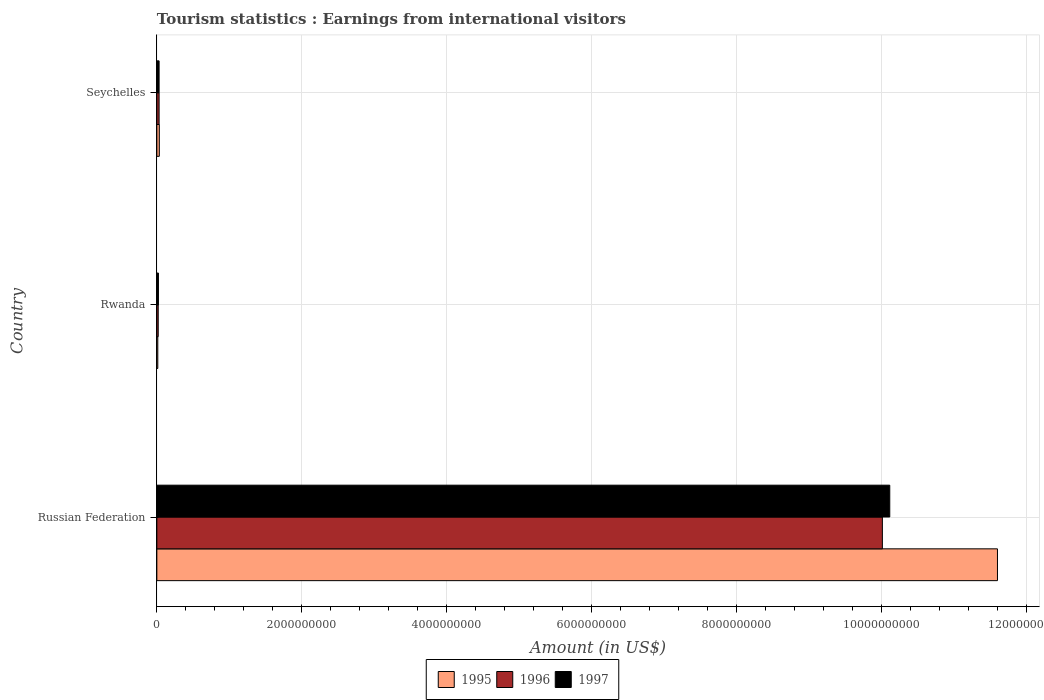How many different coloured bars are there?
Offer a terse response. 3. How many groups of bars are there?
Your answer should be very brief. 3. Are the number of bars per tick equal to the number of legend labels?
Give a very brief answer. Yes. How many bars are there on the 3rd tick from the top?
Give a very brief answer. 3. How many bars are there on the 1st tick from the bottom?
Your response must be concise. 3. What is the label of the 2nd group of bars from the top?
Keep it short and to the point. Rwanda. What is the earnings from international visitors in 1997 in Russian Federation?
Make the answer very short. 1.01e+1. Across all countries, what is the maximum earnings from international visitors in 1995?
Provide a short and direct response. 1.16e+1. Across all countries, what is the minimum earnings from international visitors in 1996?
Provide a short and direct response. 1.90e+07. In which country was the earnings from international visitors in 1997 maximum?
Your answer should be very brief. Russian Federation. In which country was the earnings from international visitors in 1996 minimum?
Provide a short and direct response. Rwanda. What is the total earnings from international visitors in 1997 in the graph?
Your answer should be compact. 1.02e+1. What is the difference between the earnings from international visitors in 1995 in Russian Federation and that in Rwanda?
Your response must be concise. 1.16e+1. What is the difference between the earnings from international visitors in 1995 in Russian Federation and the earnings from international visitors in 1996 in Rwanda?
Your response must be concise. 1.16e+1. What is the average earnings from international visitors in 1995 per country?
Your answer should be compact. 3.88e+09. What is the difference between the earnings from international visitors in 1995 and earnings from international visitors in 1997 in Rwanda?
Ensure brevity in your answer.  -9.00e+06. In how many countries, is the earnings from international visitors in 1995 greater than 9200000000 US$?
Your answer should be very brief. 1. What is the ratio of the earnings from international visitors in 1997 in Russian Federation to that in Seychelles?
Keep it short and to the point. 326.23. Is the difference between the earnings from international visitors in 1995 in Russian Federation and Rwanda greater than the difference between the earnings from international visitors in 1997 in Russian Federation and Rwanda?
Keep it short and to the point. Yes. What is the difference between the highest and the second highest earnings from international visitors in 1997?
Give a very brief answer. 1.01e+1. What is the difference between the highest and the lowest earnings from international visitors in 1997?
Keep it short and to the point. 1.01e+1. In how many countries, is the earnings from international visitors in 1996 greater than the average earnings from international visitors in 1996 taken over all countries?
Offer a terse response. 1. Is the sum of the earnings from international visitors in 1997 in Russian Federation and Rwanda greater than the maximum earnings from international visitors in 1995 across all countries?
Your response must be concise. No. What does the 1st bar from the bottom in Seychelles represents?
Offer a very short reply. 1995. Are the values on the major ticks of X-axis written in scientific E-notation?
Your answer should be compact. No. Does the graph contain grids?
Provide a short and direct response. Yes. Where does the legend appear in the graph?
Your answer should be very brief. Bottom center. How are the legend labels stacked?
Offer a terse response. Horizontal. What is the title of the graph?
Ensure brevity in your answer.  Tourism statistics : Earnings from international visitors. Does "1987" appear as one of the legend labels in the graph?
Keep it short and to the point. No. What is the label or title of the X-axis?
Make the answer very short. Amount (in US$). What is the label or title of the Y-axis?
Keep it short and to the point. Country. What is the Amount (in US$) of 1995 in Russian Federation?
Offer a very short reply. 1.16e+1. What is the Amount (in US$) of 1996 in Russian Federation?
Your response must be concise. 1.00e+1. What is the Amount (in US$) of 1997 in Russian Federation?
Give a very brief answer. 1.01e+1. What is the Amount (in US$) of 1995 in Rwanda?
Offer a very short reply. 1.30e+07. What is the Amount (in US$) in 1996 in Rwanda?
Your answer should be compact. 1.90e+07. What is the Amount (in US$) in 1997 in Rwanda?
Provide a short and direct response. 2.20e+07. What is the Amount (in US$) of 1995 in Seychelles?
Your answer should be compact. 3.40e+07. What is the Amount (in US$) of 1996 in Seychelles?
Ensure brevity in your answer.  3.10e+07. What is the Amount (in US$) of 1997 in Seychelles?
Offer a very short reply. 3.10e+07. Across all countries, what is the maximum Amount (in US$) of 1995?
Ensure brevity in your answer.  1.16e+1. Across all countries, what is the maximum Amount (in US$) of 1996?
Your answer should be compact. 1.00e+1. Across all countries, what is the maximum Amount (in US$) in 1997?
Keep it short and to the point. 1.01e+1. Across all countries, what is the minimum Amount (in US$) of 1995?
Your answer should be compact. 1.30e+07. Across all countries, what is the minimum Amount (in US$) of 1996?
Your answer should be compact. 1.90e+07. Across all countries, what is the minimum Amount (in US$) of 1997?
Provide a short and direct response. 2.20e+07. What is the total Amount (in US$) of 1995 in the graph?
Your answer should be compact. 1.16e+1. What is the total Amount (in US$) of 1996 in the graph?
Make the answer very short. 1.01e+1. What is the total Amount (in US$) of 1997 in the graph?
Offer a very short reply. 1.02e+1. What is the difference between the Amount (in US$) in 1995 in Russian Federation and that in Rwanda?
Give a very brief answer. 1.16e+1. What is the difference between the Amount (in US$) in 1996 in Russian Federation and that in Rwanda?
Give a very brief answer. 9.99e+09. What is the difference between the Amount (in US$) in 1997 in Russian Federation and that in Rwanda?
Provide a succinct answer. 1.01e+1. What is the difference between the Amount (in US$) in 1995 in Russian Federation and that in Seychelles?
Make the answer very short. 1.16e+1. What is the difference between the Amount (in US$) of 1996 in Russian Federation and that in Seychelles?
Your answer should be compact. 9.98e+09. What is the difference between the Amount (in US$) of 1997 in Russian Federation and that in Seychelles?
Your answer should be very brief. 1.01e+1. What is the difference between the Amount (in US$) in 1995 in Rwanda and that in Seychelles?
Your response must be concise. -2.10e+07. What is the difference between the Amount (in US$) in 1996 in Rwanda and that in Seychelles?
Keep it short and to the point. -1.20e+07. What is the difference between the Amount (in US$) in 1997 in Rwanda and that in Seychelles?
Your answer should be compact. -9.00e+06. What is the difference between the Amount (in US$) in 1995 in Russian Federation and the Amount (in US$) in 1996 in Rwanda?
Keep it short and to the point. 1.16e+1. What is the difference between the Amount (in US$) in 1995 in Russian Federation and the Amount (in US$) in 1997 in Rwanda?
Ensure brevity in your answer.  1.16e+1. What is the difference between the Amount (in US$) in 1996 in Russian Federation and the Amount (in US$) in 1997 in Rwanda?
Ensure brevity in your answer.  9.99e+09. What is the difference between the Amount (in US$) in 1995 in Russian Federation and the Amount (in US$) in 1996 in Seychelles?
Your response must be concise. 1.16e+1. What is the difference between the Amount (in US$) of 1995 in Russian Federation and the Amount (in US$) of 1997 in Seychelles?
Provide a succinct answer. 1.16e+1. What is the difference between the Amount (in US$) in 1996 in Russian Federation and the Amount (in US$) in 1997 in Seychelles?
Your response must be concise. 9.98e+09. What is the difference between the Amount (in US$) of 1995 in Rwanda and the Amount (in US$) of 1996 in Seychelles?
Ensure brevity in your answer.  -1.80e+07. What is the difference between the Amount (in US$) of 1995 in Rwanda and the Amount (in US$) of 1997 in Seychelles?
Provide a short and direct response. -1.80e+07. What is the difference between the Amount (in US$) in 1996 in Rwanda and the Amount (in US$) in 1997 in Seychelles?
Make the answer very short. -1.20e+07. What is the average Amount (in US$) in 1995 per country?
Provide a short and direct response. 3.88e+09. What is the average Amount (in US$) in 1996 per country?
Your response must be concise. 3.35e+09. What is the average Amount (in US$) of 1997 per country?
Your answer should be compact. 3.39e+09. What is the difference between the Amount (in US$) in 1995 and Amount (in US$) in 1996 in Russian Federation?
Provide a succinct answer. 1.59e+09. What is the difference between the Amount (in US$) in 1995 and Amount (in US$) in 1997 in Russian Federation?
Ensure brevity in your answer.  1.49e+09. What is the difference between the Amount (in US$) of 1996 and Amount (in US$) of 1997 in Russian Federation?
Offer a very short reply. -1.02e+08. What is the difference between the Amount (in US$) of 1995 and Amount (in US$) of 1996 in Rwanda?
Provide a short and direct response. -6.00e+06. What is the difference between the Amount (in US$) in 1995 and Amount (in US$) in 1997 in Rwanda?
Provide a succinct answer. -9.00e+06. What is the difference between the Amount (in US$) in 1996 and Amount (in US$) in 1997 in Rwanda?
Offer a terse response. -3.00e+06. What is the difference between the Amount (in US$) in 1995 and Amount (in US$) in 1996 in Seychelles?
Make the answer very short. 3.00e+06. What is the difference between the Amount (in US$) of 1995 and Amount (in US$) of 1997 in Seychelles?
Make the answer very short. 3.00e+06. What is the difference between the Amount (in US$) of 1996 and Amount (in US$) of 1997 in Seychelles?
Offer a terse response. 0. What is the ratio of the Amount (in US$) of 1995 in Russian Federation to that in Rwanda?
Provide a short and direct response. 892.23. What is the ratio of the Amount (in US$) in 1996 in Russian Federation to that in Rwanda?
Provide a short and direct response. 526.89. What is the ratio of the Amount (in US$) in 1997 in Russian Federation to that in Rwanda?
Offer a very short reply. 459.68. What is the ratio of the Amount (in US$) in 1995 in Russian Federation to that in Seychelles?
Offer a terse response. 341.15. What is the ratio of the Amount (in US$) in 1996 in Russian Federation to that in Seychelles?
Offer a terse response. 322.94. What is the ratio of the Amount (in US$) in 1997 in Russian Federation to that in Seychelles?
Keep it short and to the point. 326.23. What is the ratio of the Amount (in US$) of 1995 in Rwanda to that in Seychelles?
Your answer should be very brief. 0.38. What is the ratio of the Amount (in US$) of 1996 in Rwanda to that in Seychelles?
Give a very brief answer. 0.61. What is the ratio of the Amount (in US$) of 1997 in Rwanda to that in Seychelles?
Ensure brevity in your answer.  0.71. What is the difference between the highest and the second highest Amount (in US$) of 1995?
Your answer should be compact. 1.16e+1. What is the difference between the highest and the second highest Amount (in US$) in 1996?
Your response must be concise. 9.98e+09. What is the difference between the highest and the second highest Amount (in US$) in 1997?
Offer a very short reply. 1.01e+1. What is the difference between the highest and the lowest Amount (in US$) of 1995?
Offer a very short reply. 1.16e+1. What is the difference between the highest and the lowest Amount (in US$) of 1996?
Keep it short and to the point. 9.99e+09. What is the difference between the highest and the lowest Amount (in US$) of 1997?
Give a very brief answer. 1.01e+1. 